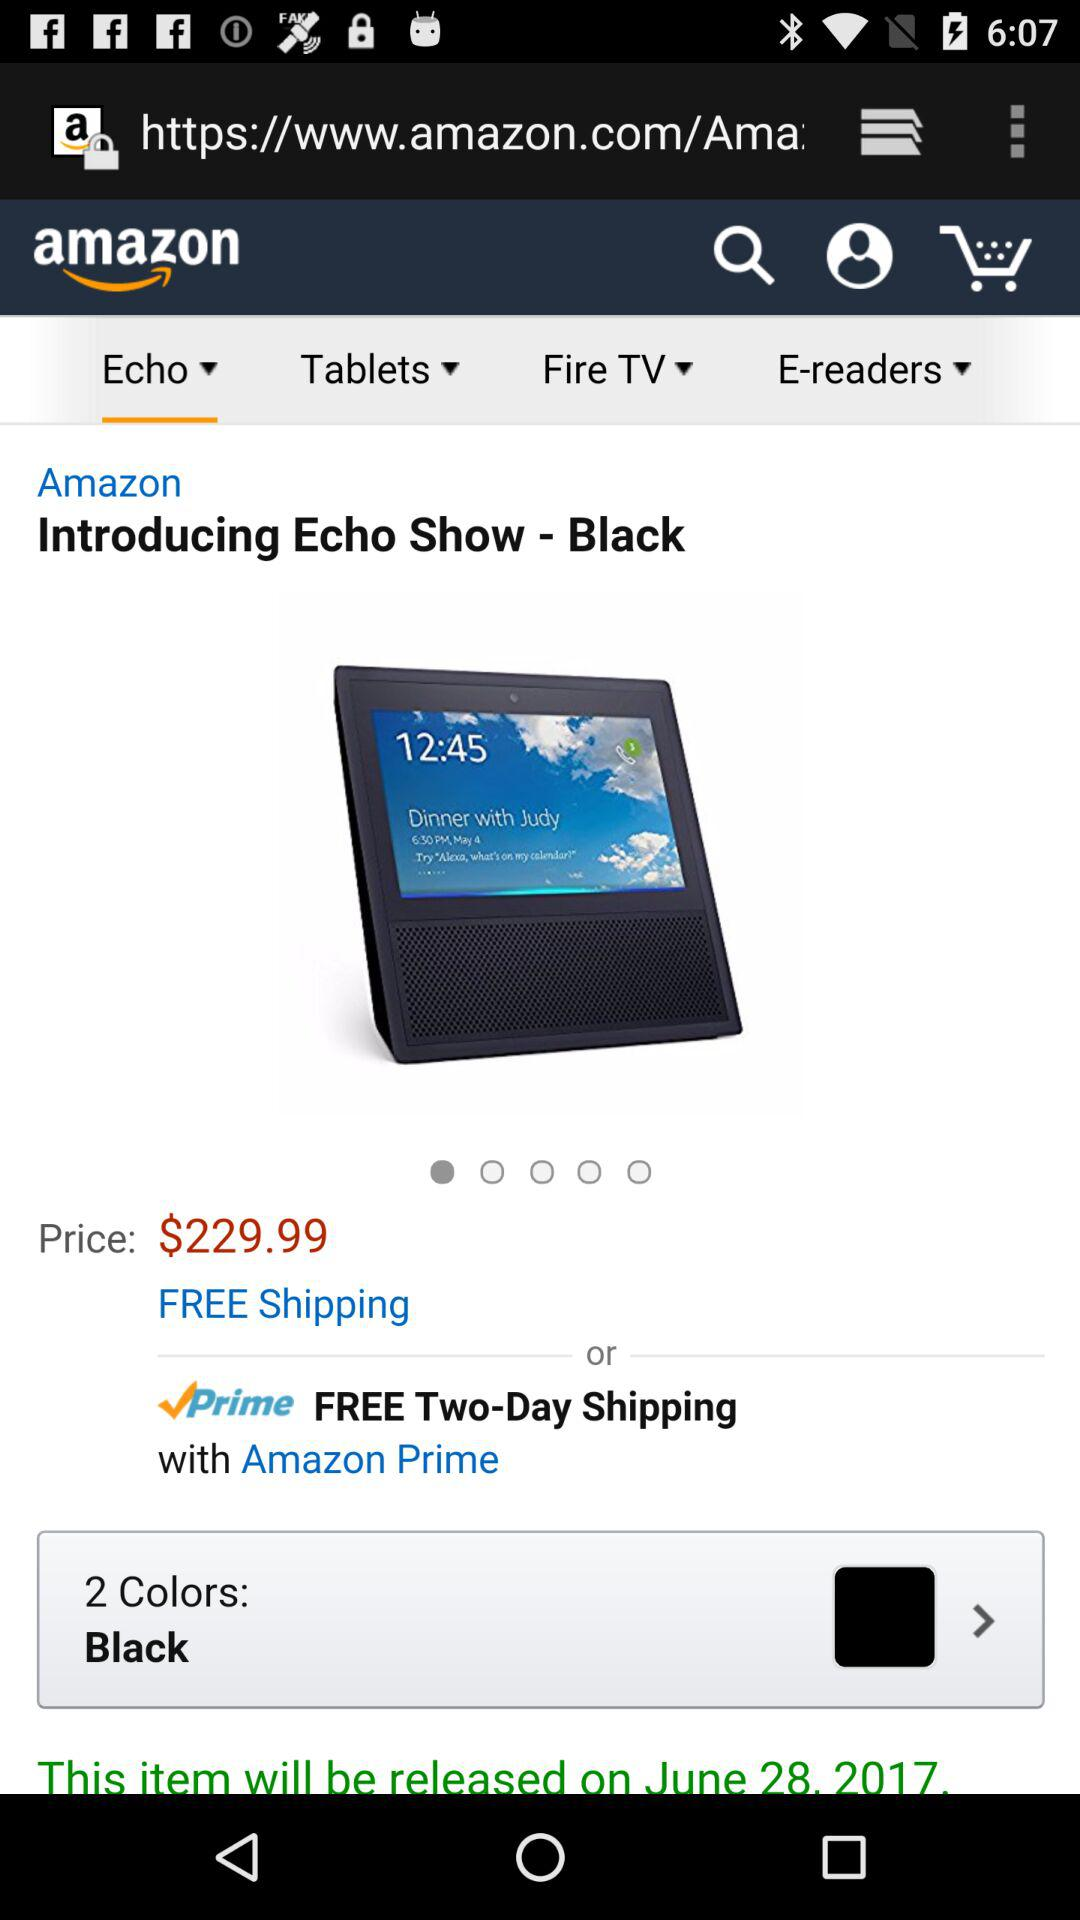What is the selected tab? The selected tab is "Echo". 